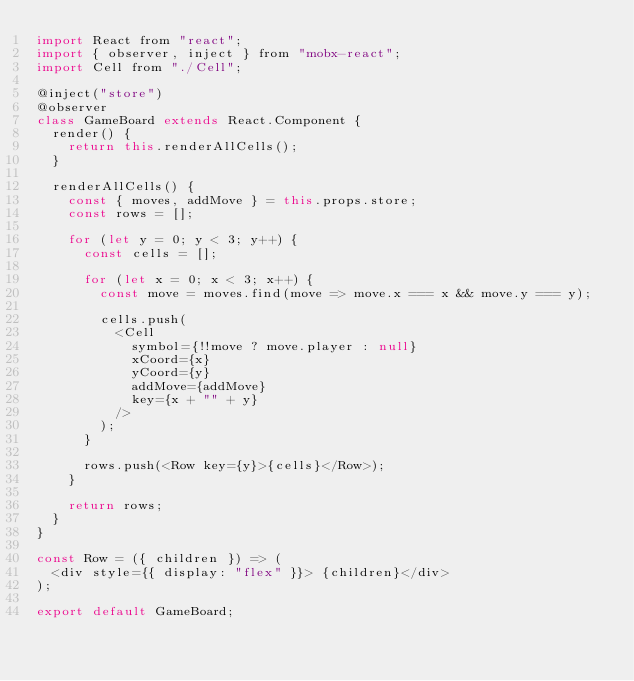<code> <loc_0><loc_0><loc_500><loc_500><_JavaScript_>import React from "react";
import { observer, inject } from "mobx-react";
import Cell from "./Cell";

@inject("store")
@observer
class GameBoard extends React.Component {
  render() {
    return this.renderAllCells();
  }

  renderAllCells() {
    const { moves, addMove } = this.props.store;
    const rows = [];

    for (let y = 0; y < 3; y++) {
      const cells = [];

      for (let x = 0; x < 3; x++) {
        const move = moves.find(move => move.x === x && move.y === y);

        cells.push(
          <Cell
            symbol={!!move ? move.player : null}
            xCoord={x}
            yCoord={y}
            addMove={addMove}
            key={x + "" + y}
          />
        );
      }

      rows.push(<Row key={y}>{cells}</Row>);
    }

    return rows;
  }
}

const Row = ({ children }) => (
  <div style={{ display: "flex" }}> {children}</div>
);

export default GameBoard;
</code> 